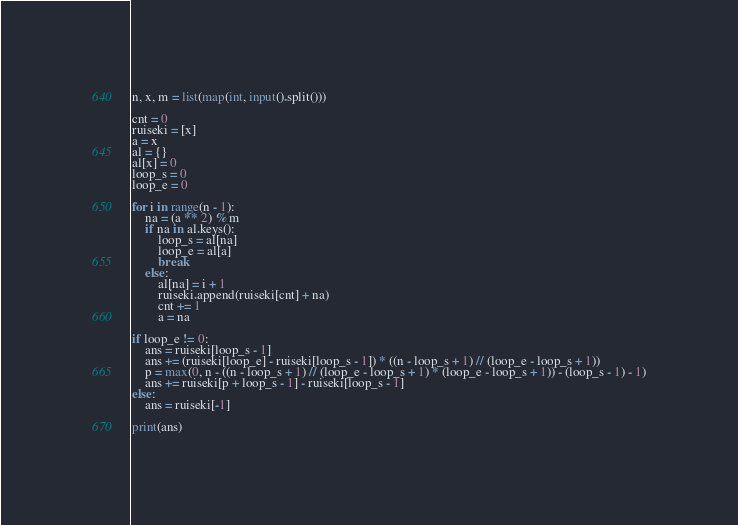<code> <loc_0><loc_0><loc_500><loc_500><_Python_>n, x, m = list(map(int, input().split()))

cnt = 0
ruiseki = [x]
a = x
al = {}
al[x] = 0
loop_s = 0
loop_e = 0

for i in range(n - 1):
    na = (a ** 2) % m
    if na in al.keys():
        loop_s = al[na]
        loop_e = al[a]
        break
    else:
        al[na] = i + 1
        ruiseki.append(ruiseki[cnt] + na)
        cnt += 1
        a = na

if loop_e != 0:
    ans = ruiseki[loop_s - 1]
    ans += (ruiseki[loop_e] - ruiseki[loop_s - 1]) * ((n - loop_s + 1) // (loop_e - loop_s + 1))
    p = max(0, n - ((n - loop_s + 1) // (loop_e - loop_s + 1) * (loop_e - loop_s + 1)) - (loop_s - 1) - 1)
    ans += ruiseki[p + loop_s - 1] - ruiseki[loop_s - 1]
else:
    ans = ruiseki[-1]

print(ans)
</code> 